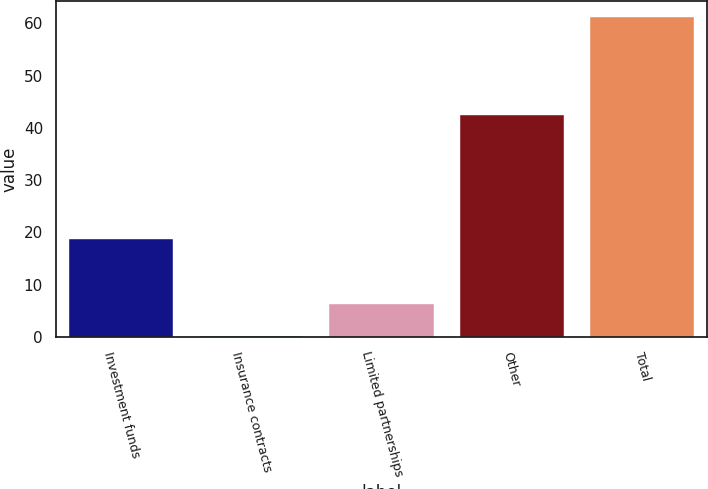Convert chart to OTSL. <chart><loc_0><loc_0><loc_500><loc_500><bar_chart><fcel>Investment funds<fcel>Insurance contracts<fcel>Limited partnerships<fcel>Other<fcel>Total<nl><fcel>18.8<fcel>0.22<fcel>6.32<fcel>42.4<fcel>61.2<nl></chart> 